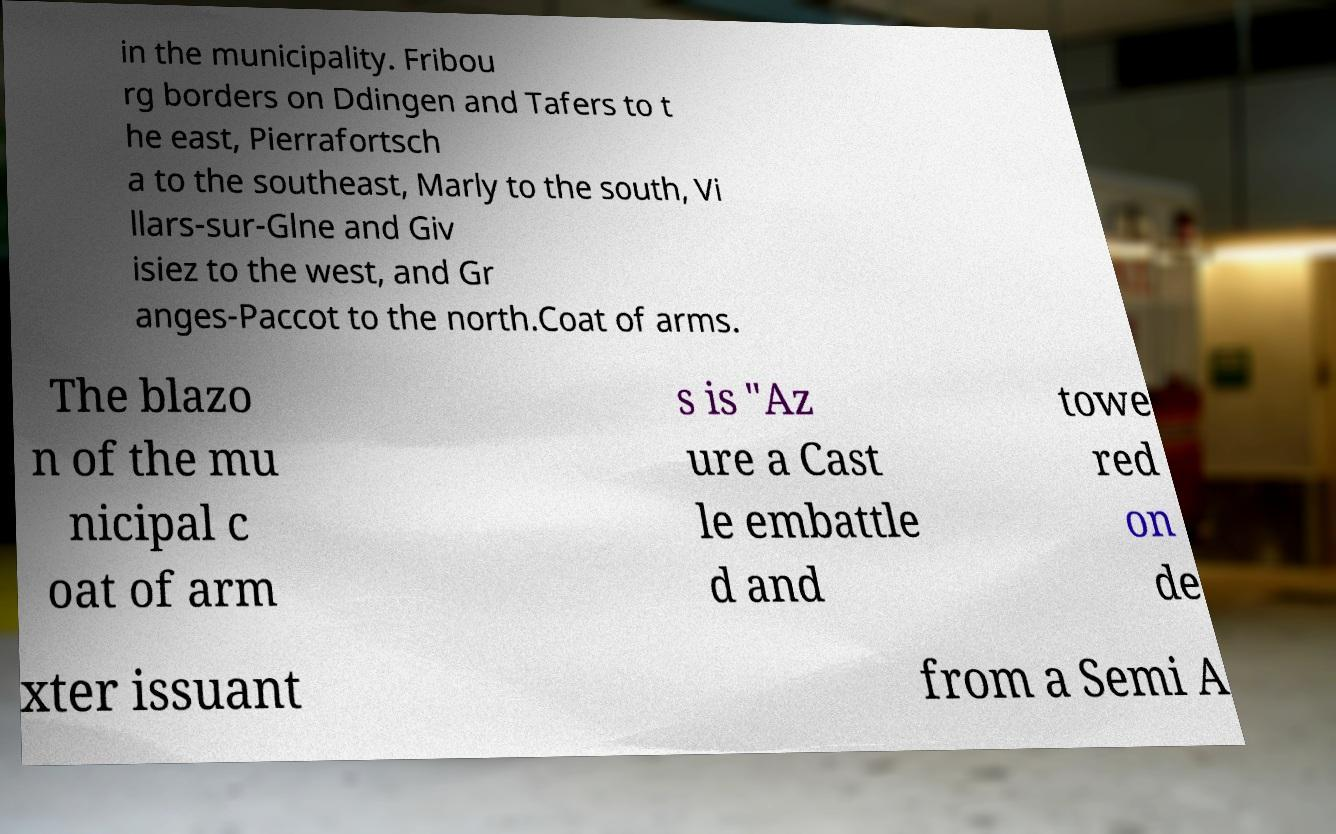Can you read and provide the text displayed in the image?This photo seems to have some interesting text. Can you extract and type it out for me? in the municipality. Fribou rg borders on Ddingen and Tafers to t he east, Pierrafortsch a to the southeast, Marly to the south, Vi llars-sur-Glne and Giv isiez to the west, and Gr anges-Paccot to the north.Coat of arms. The blazo n of the mu nicipal c oat of arm s is "Az ure a Cast le embattle d and towe red on de xter issuant from a Semi A 